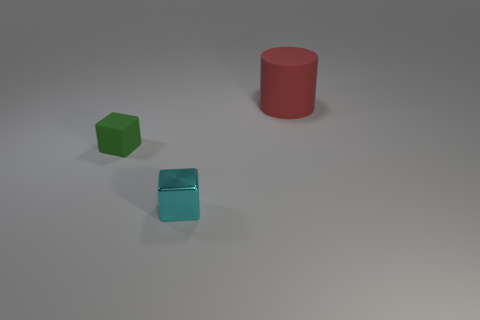Is there anything else that is the same color as the cylinder?
Your answer should be very brief. No. What number of things are either large red matte cylinders or cyan shiny objects?
Your answer should be compact. 2. Does the rubber object that is left of the red cylinder have the same size as the large matte object?
Your response must be concise. No. What number of other things are the same size as the red cylinder?
Make the answer very short. 0. Are there any small brown cylinders?
Your answer should be very brief. No. There is a cube that is behind the small cube that is on the right side of the small green block; what is its size?
Provide a short and direct response. Small. Is the color of the rubber object on the left side of the large matte object the same as the tiny object that is to the right of the green rubber thing?
Keep it short and to the point. No. There is a object that is both in front of the big red object and right of the small green rubber cube; what color is it?
Offer a terse response. Cyan. How many other things are the same shape as the large red rubber object?
Give a very brief answer. 0. The matte cube that is the same size as the cyan shiny block is what color?
Ensure brevity in your answer.  Green. 